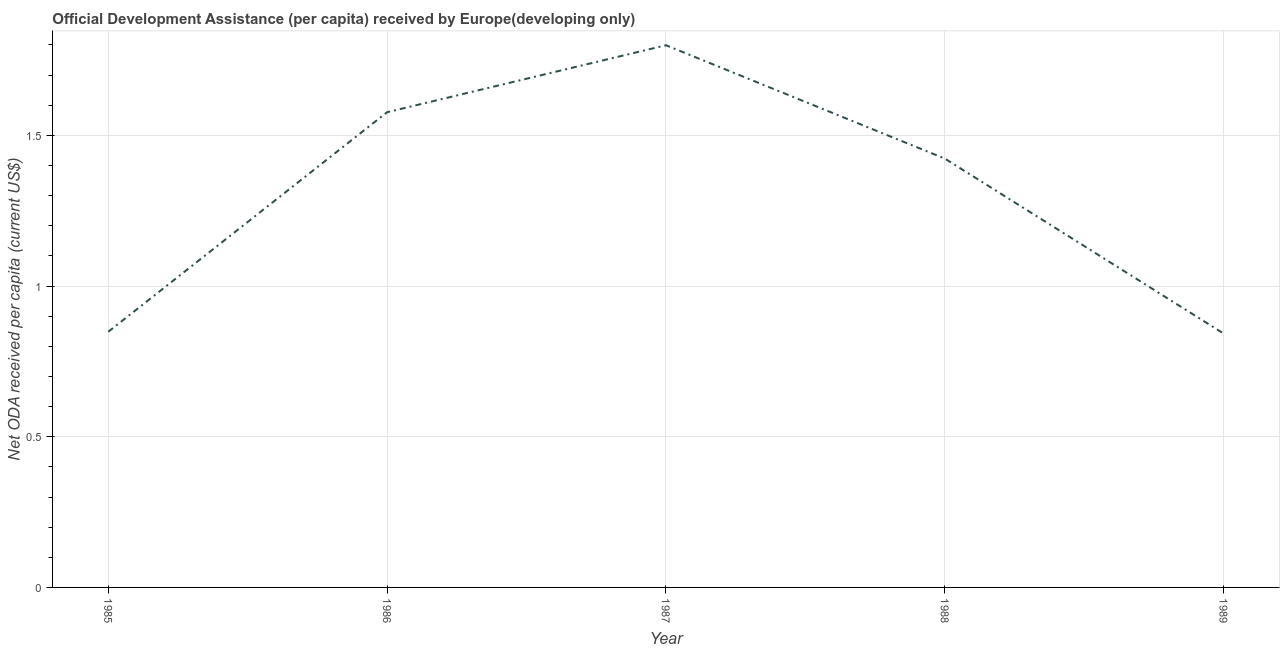What is the net oda received per capita in 1987?
Give a very brief answer. 1.8. Across all years, what is the maximum net oda received per capita?
Ensure brevity in your answer.  1.8. Across all years, what is the minimum net oda received per capita?
Your answer should be compact. 0.84. In which year was the net oda received per capita maximum?
Offer a terse response. 1987. In which year was the net oda received per capita minimum?
Provide a succinct answer. 1989. What is the sum of the net oda received per capita?
Provide a succinct answer. 6.49. What is the difference between the net oda received per capita in 1988 and 1989?
Make the answer very short. 0.58. What is the average net oda received per capita per year?
Your answer should be compact. 1.3. What is the median net oda received per capita?
Ensure brevity in your answer.  1.42. What is the ratio of the net oda received per capita in 1988 to that in 1989?
Ensure brevity in your answer.  1.69. Is the net oda received per capita in 1986 less than that in 1988?
Make the answer very short. No. What is the difference between the highest and the second highest net oda received per capita?
Your answer should be compact. 0.22. Is the sum of the net oda received per capita in 1985 and 1989 greater than the maximum net oda received per capita across all years?
Offer a very short reply. No. What is the difference between the highest and the lowest net oda received per capita?
Your answer should be very brief. 0.96. Does the net oda received per capita monotonically increase over the years?
Your answer should be compact. No. How many lines are there?
Ensure brevity in your answer.  1. How many years are there in the graph?
Keep it short and to the point. 5. What is the difference between two consecutive major ticks on the Y-axis?
Give a very brief answer. 0.5. Are the values on the major ticks of Y-axis written in scientific E-notation?
Your response must be concise. No. Does the graph contain any zero values?
Your answer should be very brief. No. What is the title of the graph?
Offer a terse response. Official Development Assistance (per capita) received by Europe(developing only). What is the label or title of the X-axis?
Ensure brevity in your answer.  Year. What is the label or title of the Y-axis?
Your answer should be compact. Net ODA received per capita (current US$). What is the Net ODA received per capita (current US$) of 1985?
Provide a succinct answer. 0.85. What is the Net ODA received per capita (current US$) in 1986?
Make the answer very short. 1.58. What is the Net ODA received per capita (current US$) of 1987?
Provide a short and direct response. 1.8. What is the Net ODA received per capita (current US$) in 1988?
Provide a succinct answer. 1.42. What is the Net ODA received per capita (current US$) in 1989?
Keep it short and to the point. 0.84. What is the difference between the Net ODA received per capita (current US$) in 1985 and 1986?
Ensure brevity in your answer.  -0.73. What is the difference between the Net ODA received per capita (current US$) in 1985 and 1987?
Give a very brief answer. -0.95. What is the difference between the Net ODA received per capita (current US$) in 1985 and 1988?
Offer a very short reply. -0.57. What is the difference between the Net ODA received per capita (current US$) in 1985 and 1989?
Keep it short and to the point. 0.01. What is the difference between the Net ODA received per capita (current US$) in 1986 and 1987?
Your answer should be very brief. -0.22. What is the difference between the Net ODA received per capita (current US$) in 1986 and 1988?
Your answer should be compact. 0.15. What is the difference between the Net ODA received per capita (current US$) in 1986 and 1989?
Your answer should be very brief. 0.73. What is the difference between the Net ODA received per capita (current US$) in 1987 and 1988?
Give a very brief answer. 0.38. What is the difference between the Net ODA received per capita (current US$) in 1987 and 1989?
Offer a terse response. 0.96. What is the difference between the Net ODA received per capita (current US$) in 1988 and 1989?
Give a very brief answer. 0.58. What is the ratio of the Net ODA received per capita (current US$) in 1985 to that in 1986?
Provide a succinct answer. 0.54. What is the ratio of the Net ODA received per capita (current US$) in 1985 to that in 1987?
Give a very brief answer. 0.47. What is the ratio of the Net ODA received per capita (current US$) in 1985 to that in 1988?
Make the answer very short. 0.6. What is the ratio of the Net ODA received per capita (current US$) in 1985 to that in 1989?
Keep it short and to the point. 1.01. What is the ratio of the Net ODA received per capita (current US$) in 1986 to that in 1987?
Your response must be concise. 0.88. What is the ratio of the Net ODA received per capita (current US$) in 1986 to that in 1988?
Give a very brief answer. 1.11. What is the ratio of the Net ODA received per capita (current US$) in 1986 to that in 1989?
Provide a succinct answer. 1.87. What is the ratio of the Net ODA received per capita (current US$) in 1987 to that in 1988?
Make the answer very short. 1.26. What is the ratio of the Net ODA received per capita (current US$) in 1987 to that in 1989?
Give a very brief answer. 2.14. What is the ratio of the Net ODA received per capita (current US$) in 1988 to that in 1989?
Your answer should be compact. 1.69. 